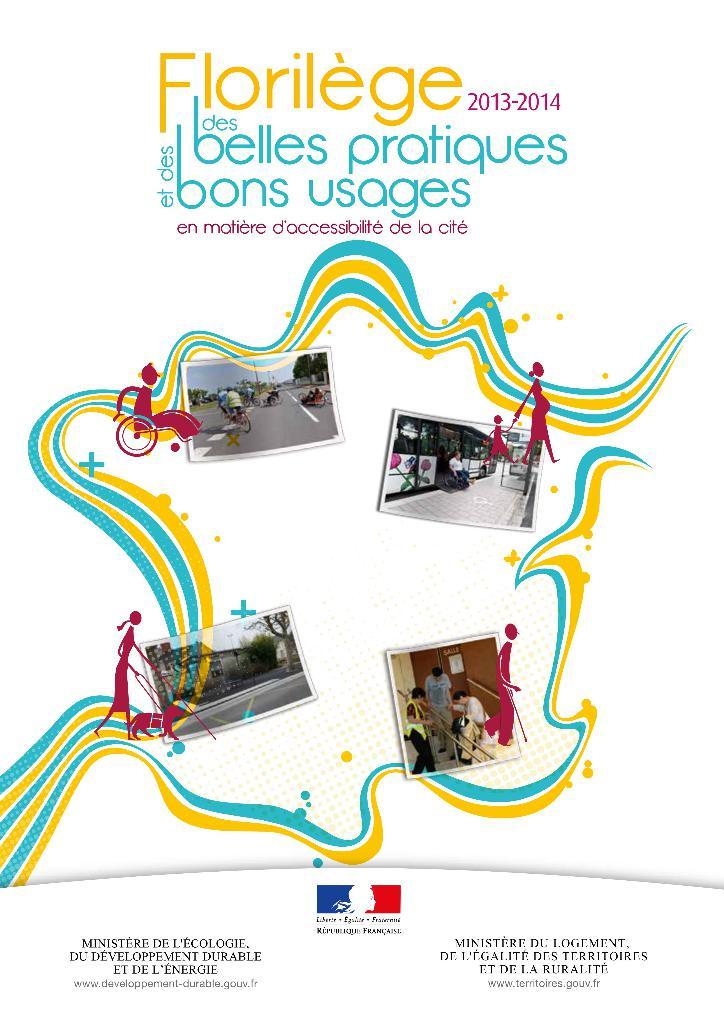What is present in the image that contains visual and written information? There is a poster in the image that contains images and text. Can you describe the content of the poster? The poster contains images and text, but the specific content cannot be determined from the provided facts. How many girls are standing on the bridge in the image? There is no bridge or girls present in the image; it only contains a poster with images and text. 